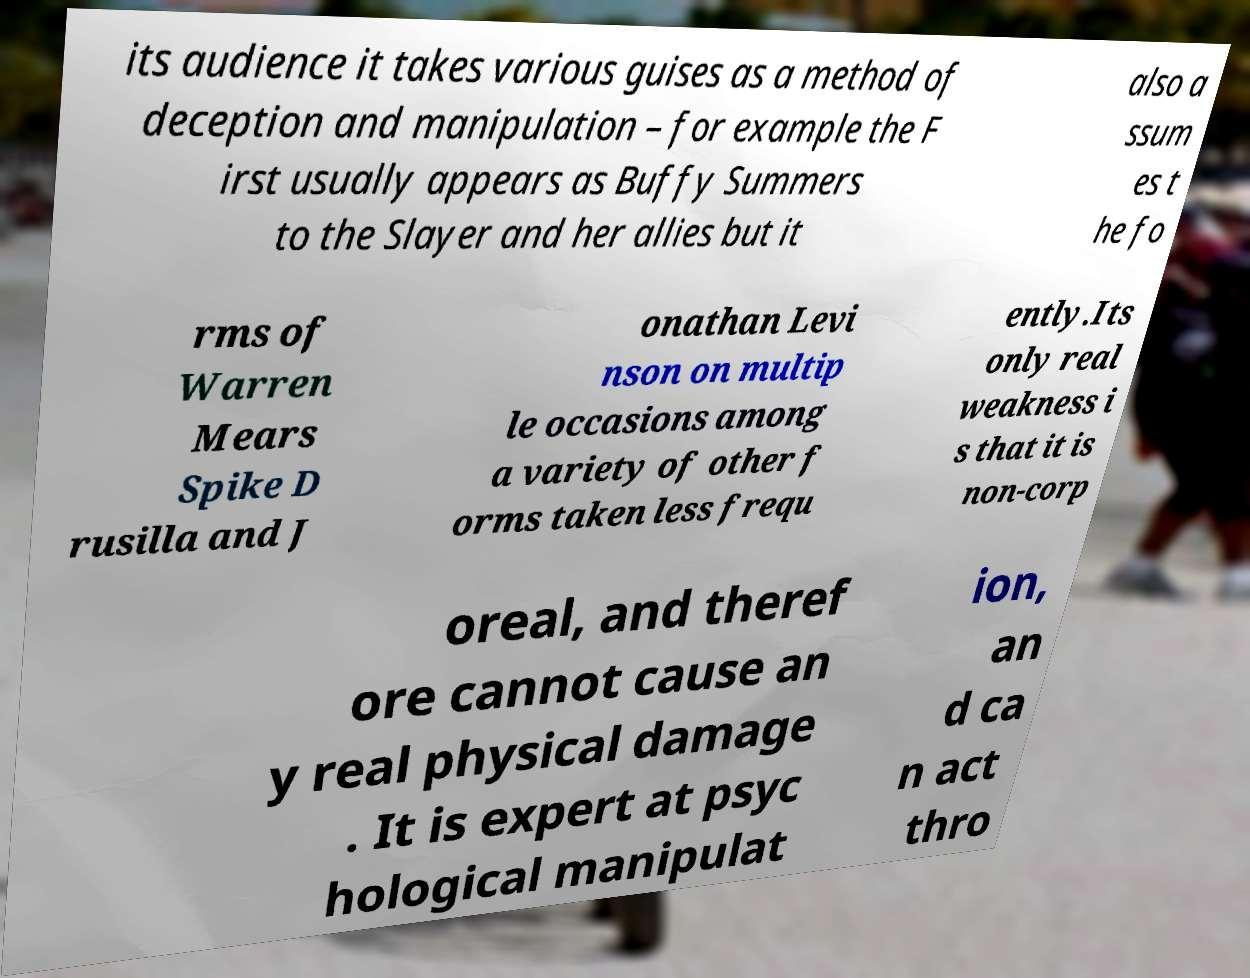Can you read and provide the text displayed in the image?This photo seems to have some interesting text. Can you extract and type it out for me? its audience it takes various guises as a method of deception and manipulation – for example the F irst usually appears as Buffy Summers to the Slayer and her allies but it also a ssum es t he fo rms of Warren Mears Spike D rusilla and J onathan Levi nson on multip le occasions among a variety of other f orms taken less frequ ently.Its only real weakness i s that it is non-corp oreal, and theref ore cannot cause an y real physical damage . It is expert at psyc hological manipulat ion, an d ca n act thro 